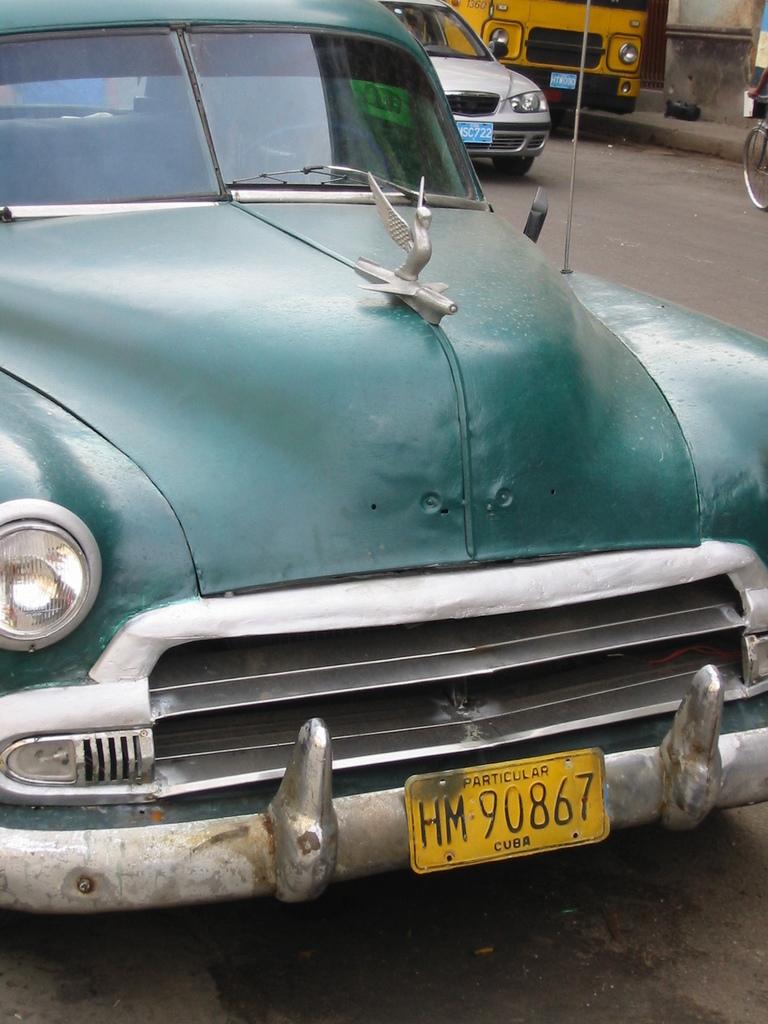What is the license plate number of this oldie?
Keep it short and to the point. Hm 90867. Is particular a city in cuba?
Offer a terse response. Yes. 